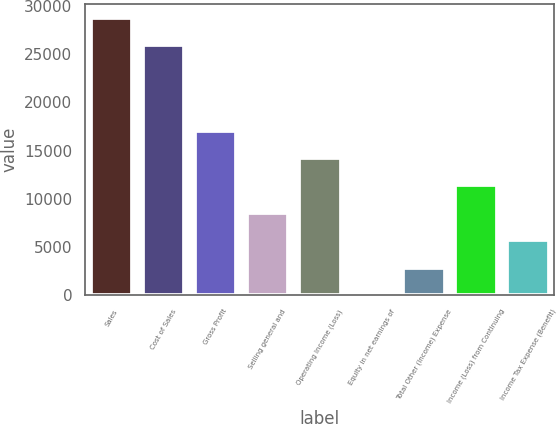Convert chart to OTSL. <chart><loc_0><loc_0><loc_500><loc_500><bar_chart><fcel>Sales<fcel>Cost of Sales<fcel>Gross Profit<fcel>Selling general and<fcel>Operating Income (Loss)<fcel>Equity in net earnings of<fcel>Total Other (Income) Expense<fcel>Income (Loss) from Continuing<fcel>Income Tax Expense (Benefit)<nl><fcel>28758.5<fcel>25916<fcel>17059.8<fcel>8532.19<fcel>14217.3<fcel>4.54<fcel>2847.09<fcel>11374.7<fcel>5689.64<nl></chart> 